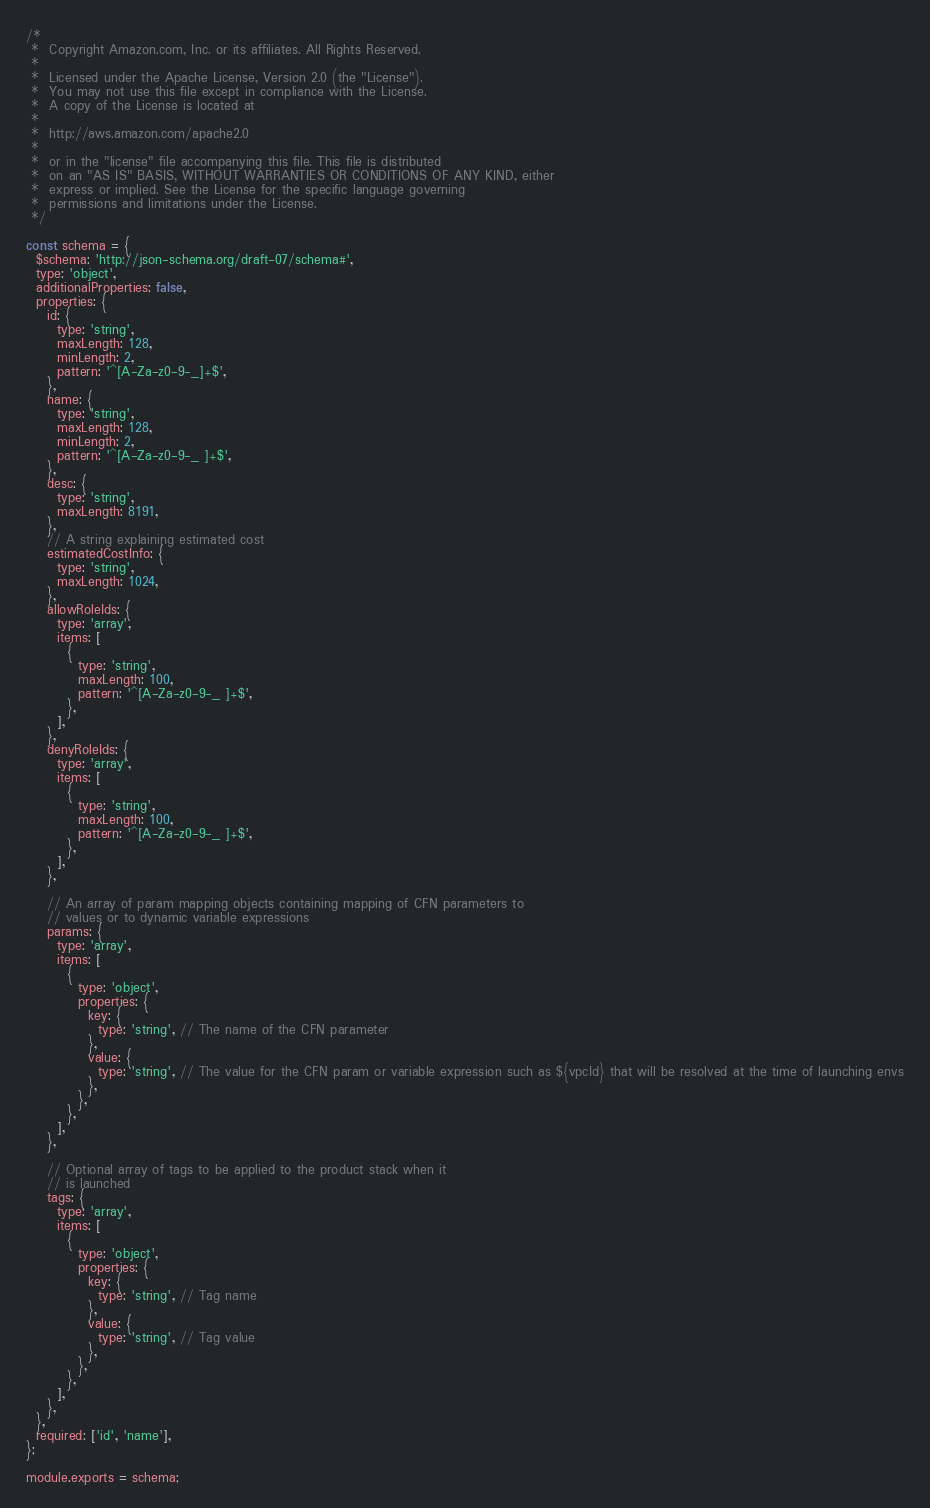<code> <loc_0><loc_0><loc_500><loc_500><_JavaScript_>/*
 *  Copyright Amazon.com, Inc. or its affiliates. All Rights Reserved.
 *
 *  Licensed under the Apache License, Version 2.0 (the "License").
 *  You may not use this file except in compliance with the License.
 *  A copy of the License is located at
 *
 *  http://aws.amazon.com/apache2.0
 *
 *  or in the "license" file accompanying this file. This file is distributed
 *  on an "AS IS" BASIS, WITHOUT WARRANTIES OR CONDITIONS OF ANY KIND, either
 *  express or implied. See the License for the specific language governing
 *  permissions and limitations under the License.
 */

const schema = {
  $schema: 'http://json-schema.org/draft-07/schema#',
  type: 'object',
  additionalProperties: false,
  properties: {
    id: {
      type: 'string',
      maxLength: 128,
      minLength: 2,
      pattern: '^[A-Za-z0-9-_]+$',
    },
    name: {
      type: 'string',
      maxLength: 128,
      minLength: 2,
      pattern: '^[A-Za-z0-9-_ ]+$',
    },
    desc: {
      type: 'string',
      maxLength: 8191,
    },
    // A string explaining estimated cost
    estimatedCostInfo: {
      type: 'string',
      maxLength: 1024,
    },
    allowRoleIds: {
      type: 'array',
      items: [
        {
          type: 'string',
          maxLength: 100,
          pattern: '^[A-Za-z0-9-_ ]+$',
        },
      ],
    },
    denyRoleIds: {
      type: 'array',
      items: [
        {
          type: 'string',
          maxLength: 100,
          pattern: '^[A-Za-z0-9-_ ]+$',
        },
      ],
    },

    // An array of param mapping objects containing mapping of CFN parameters to
    // values or to dynamic variable expressions
    params: {
      type: 'array',
      items: [
        {
          type: 'object',
          properties: {
            key: {
              type: 'string', // The name of the CFN parameter
            },
            value: {
              type: 'string', // The value for the CFN param or variable expression such as ${vpcId} that will be resolved at the time of launching envs
            },
          },
        },
      ],
    },

    // Optional array of tags to be applied to the product stack when it
    // is launched
    tags: {
      type: 'array',
      items: [
        {
          type: 'object',
          properties: {
            key: {
              type: 'string', // Tag name
            },
            value: {
              type: 'string', // Tag value
            },
          },
        },
      ],
    },
  },
  required: ['id', 'name'],
};

module.exports = schema;
</code> 